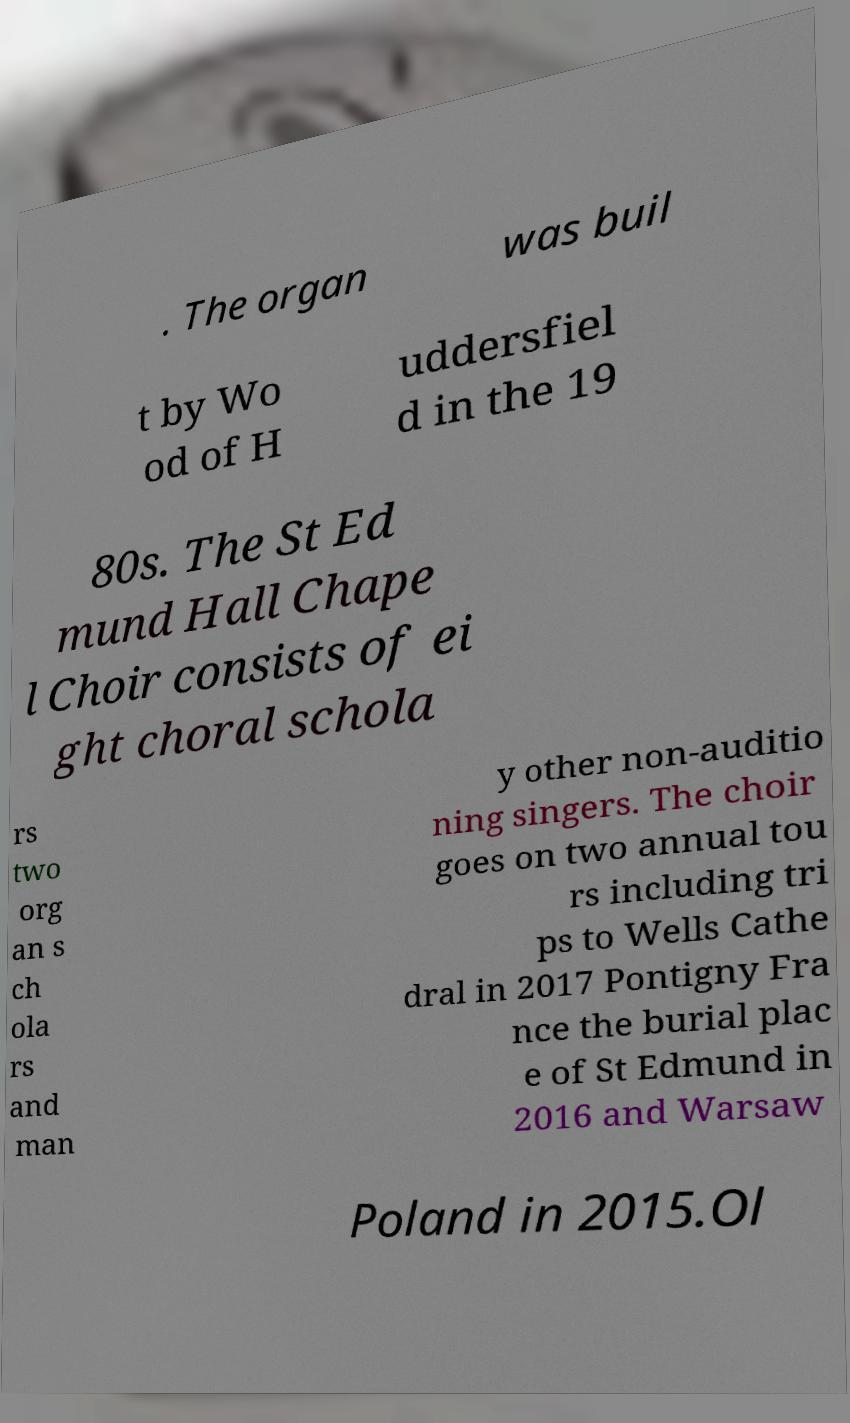Could you extract and type out the text from this image? . The organ was buil t by Wo od of H uddersfiel d in the 19 80s. The St Ed mund Hall Chape l Choir consists of ei ght choral schola rs two org an s ch ola rs and man y other non-auditio ning singers. The choir goes on two annual tou rs including tri ps to Wells Cathe dral in 2017 Pontigny Fra nce the burial plac e of St Edmund in 2016 and Warsaw Poland in 2015.Ol 